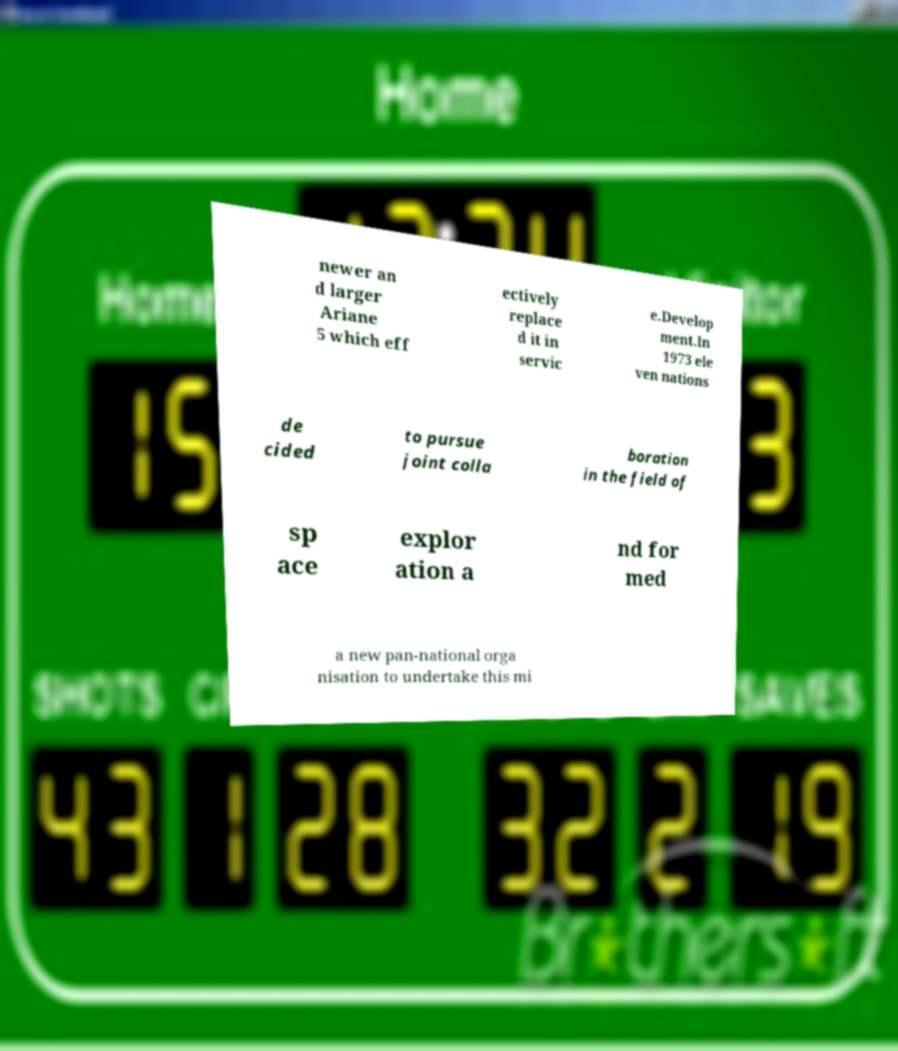Please identify and transcribe the text found in this image. newer an d larger Ariane 5 which eff ectively replace d it in servic e.Develop ment.In 1973 ele ven nations de cided to pursue joint colla boration in the field of sp ace explor ation a nd for med a new pan-national orga nisation to undertake this mi 